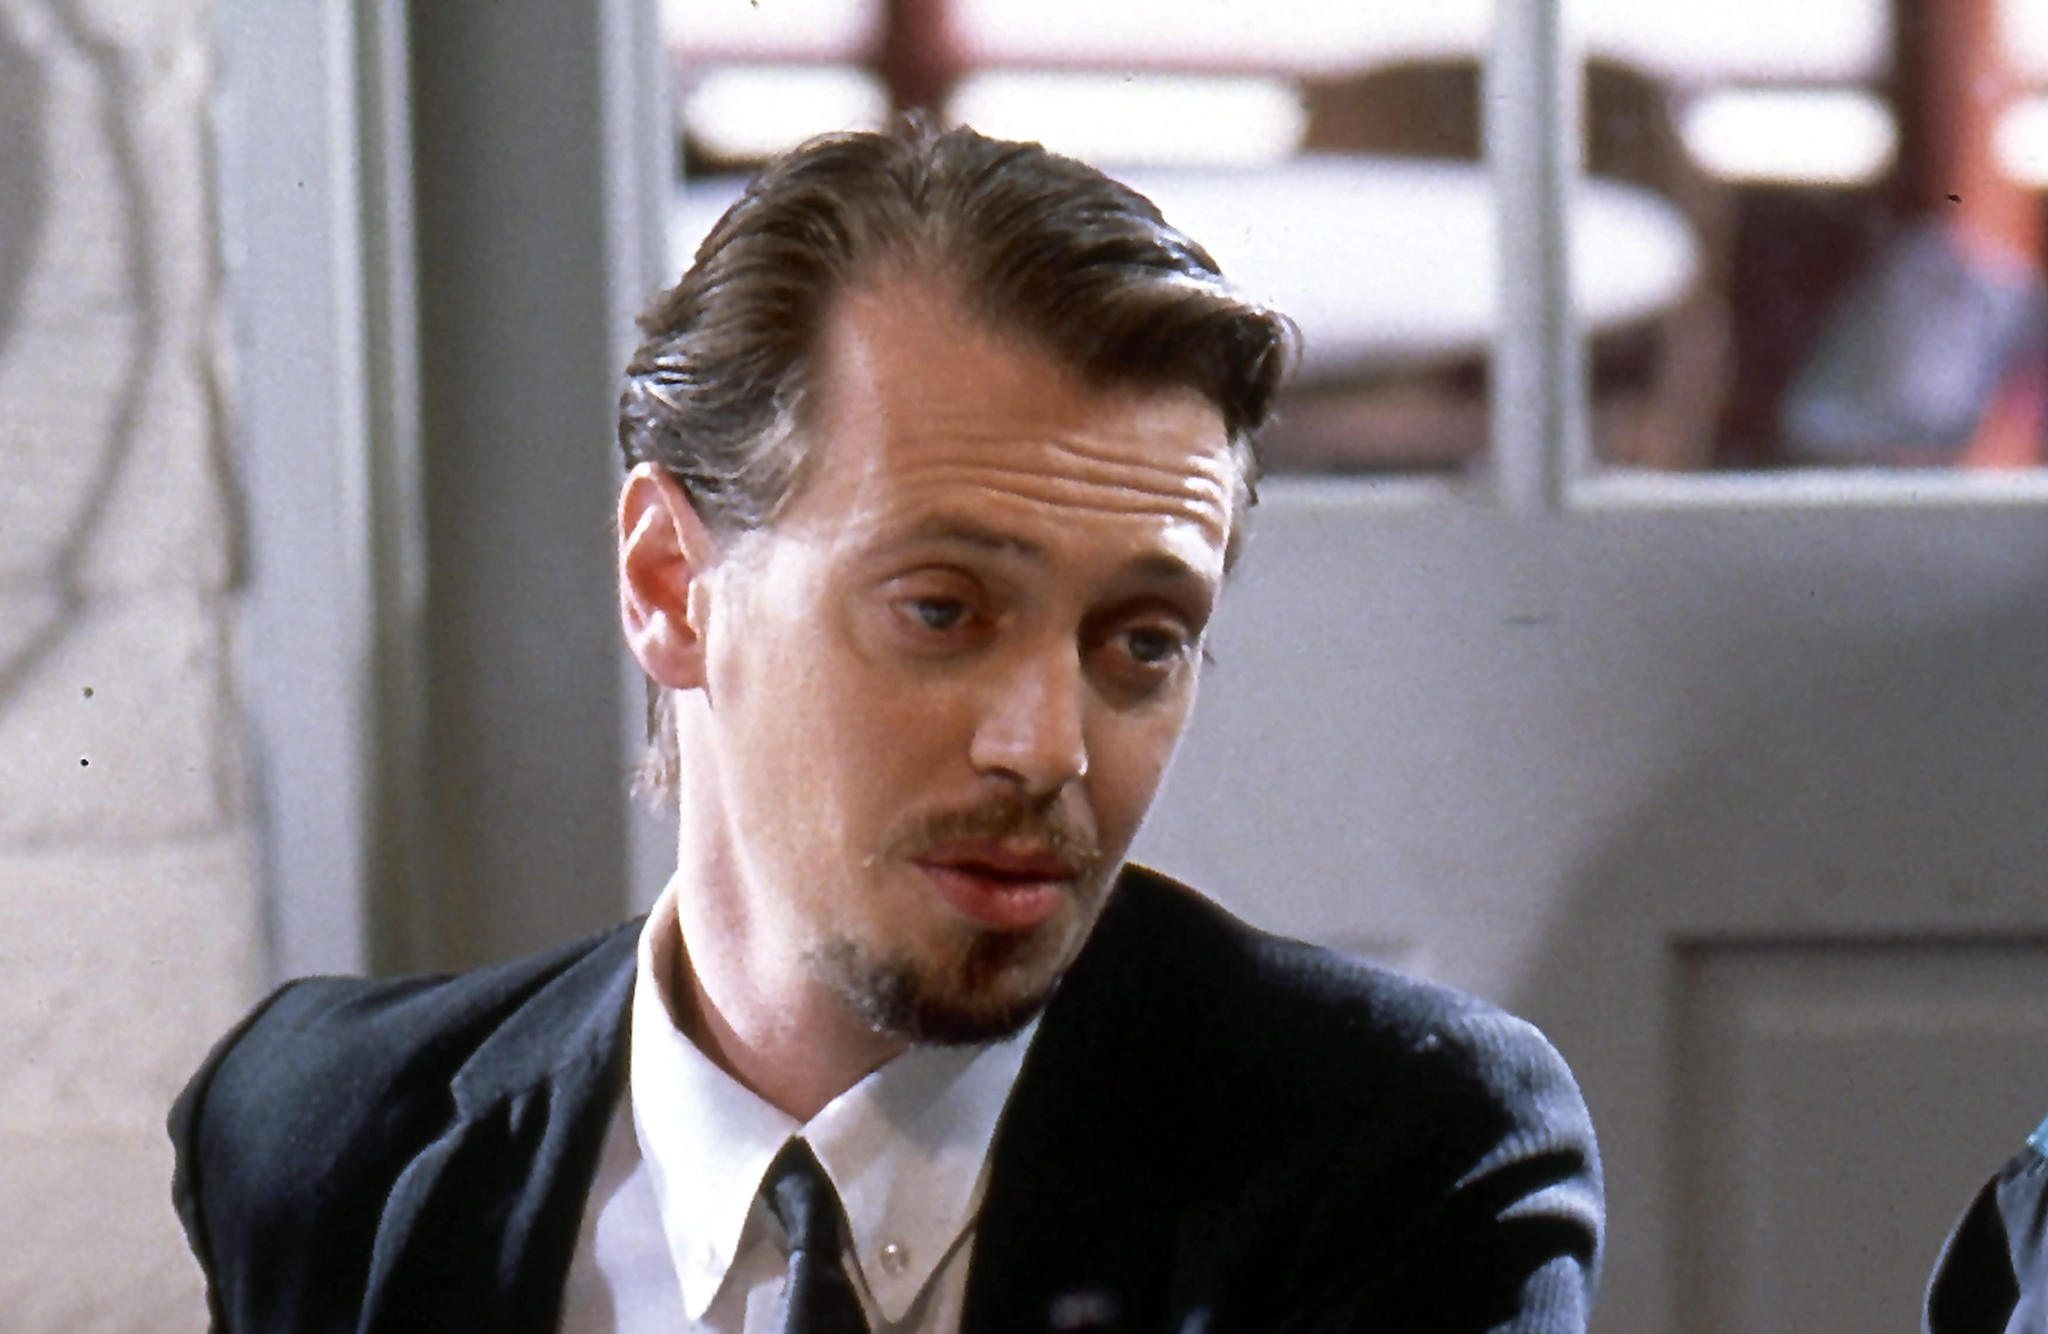Describe the atmosphere and mood that is conveyed in this scene. The atmosphere in this scene is one of introspection and contemplation. The character, Mr. Pink, portrayed by Steve Buscemi, is dressed in a black suit that adds a serious tone to the image. His gaze is deep and thoughtful, suggesting he is pondering something significant. The background, slightly blurred, indicates a public setting, possibly a diner or café, which adds a sense of normalcy and realism to the scene. The subdued lighting and muted colors contribute to a somber and reflective mood. 